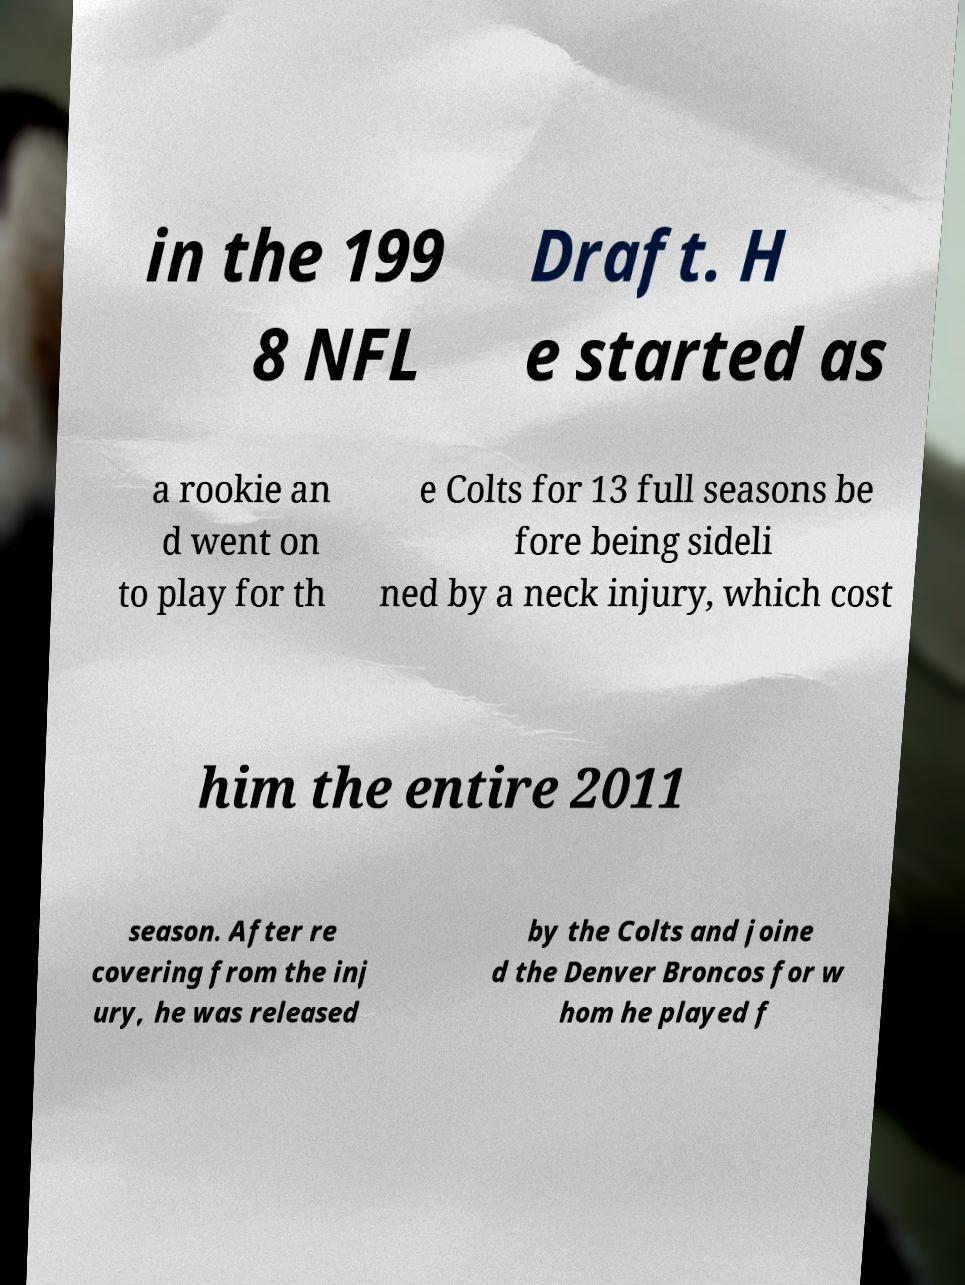There's text embedded in this image that I need extracted. Can you transcribe it verbatim? in the 199 8 NFL Draft. H e started as a rookie an d went on to play for th e Colts for 13 full seasons be fore being sideli ned by a neck injury, which cost him the entire 2011 season. After re covering from the inj ury, he was released by the Colts and joine d the Denver Broncos for w hom he played f 